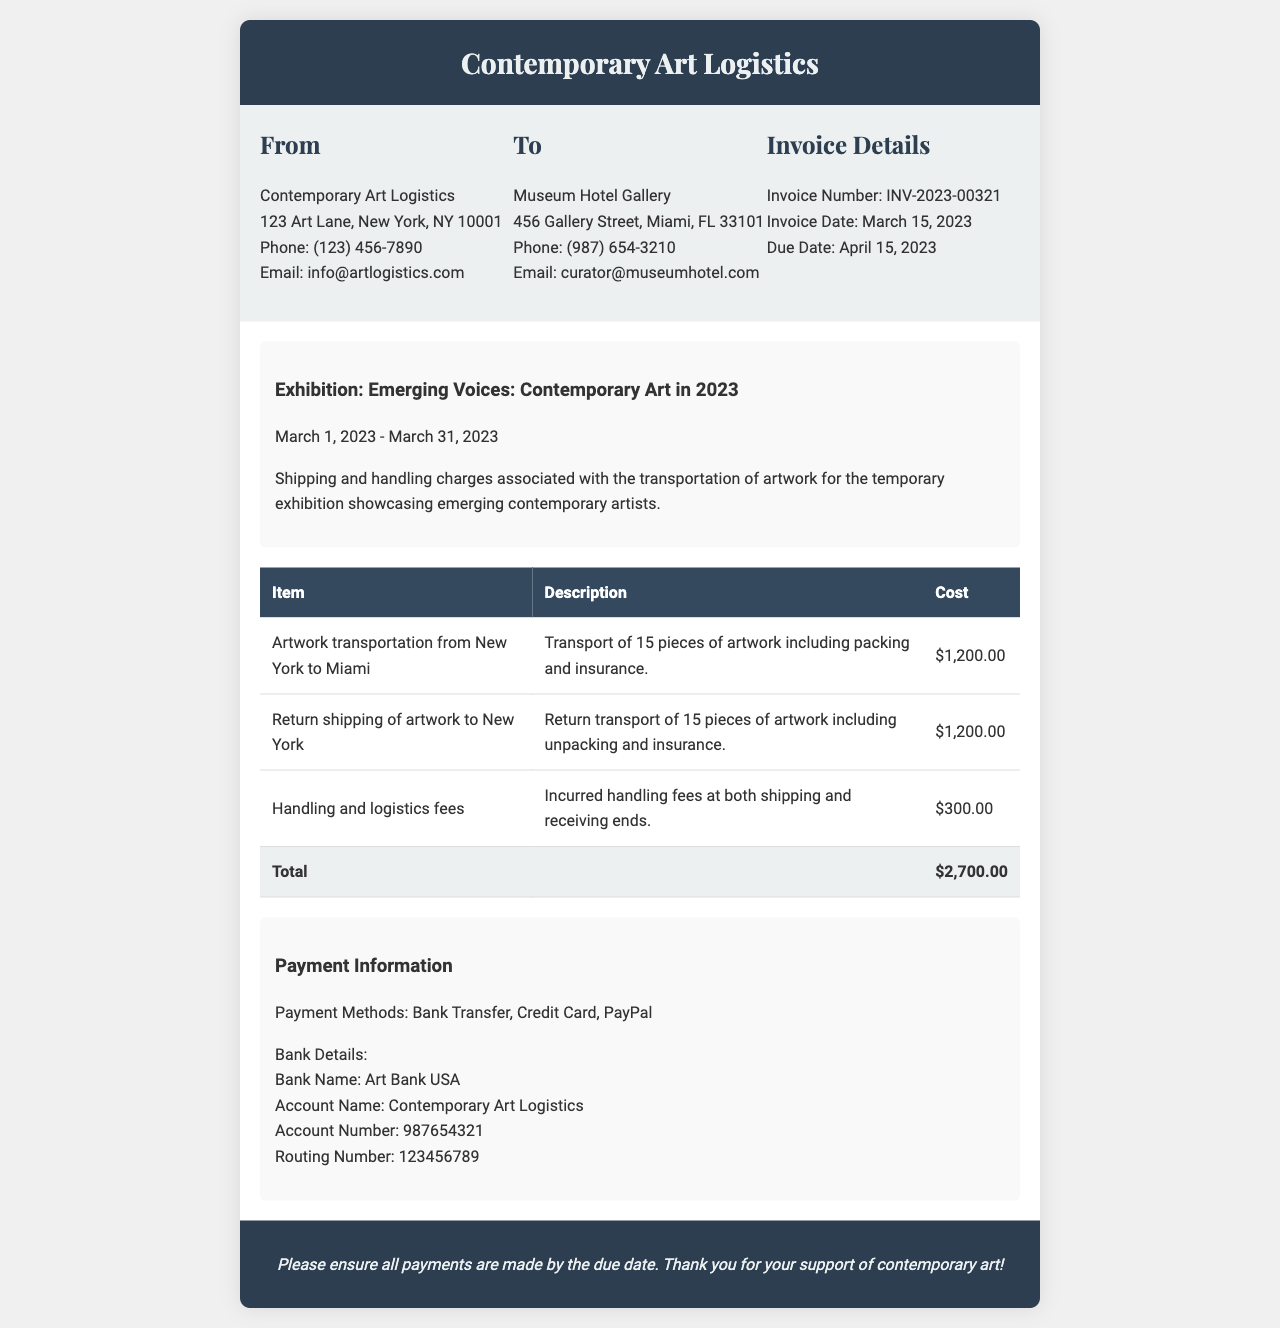What is the invoice number? The invoice number is provided in the invoice details section, which specifies the unique identifier for this invoice.
Answer: INV-2023-00321 What is the total cost of shipping and handling? The total cost is calculated by summing all individual costs for the services listed in the invoice.
Answer: $2,700.00 What is the due date for payment? The due date is specified in the invoice details as the date by which payment must be made.
Answer: April 15, 2023 Which exhibition is associated with this invoice? The invoice mentions the exhibition title under the invoice description, indicating the event related to the service provided.
Answer: Emerging Voices: Contemporary Art in 2023 How many pieces of artwork were transported? The number of pieces is mentioned in the description of the transportation services provided.
Answer: 15 pieces What is the cost of handling and logistics fees? The cost is outlined in the items listed on the invoice, which includes handling fees.
Answer: $300.00 Where is the shipping origin for the artwork? The origin for the artwork's transportation is mentioned in the itemized list, indicating where the artwork was shipped from.
Answer: New York What payment methods are accepted? The payment methods section specifies the ways in which payment for the invoice can be made.
Answer: Bank Transfer, Credit Card, PayPal Who should payments be made to? The payment information provides the name of the entity to whom payments should be directed.
Answer: Contemporary Art Logistics 